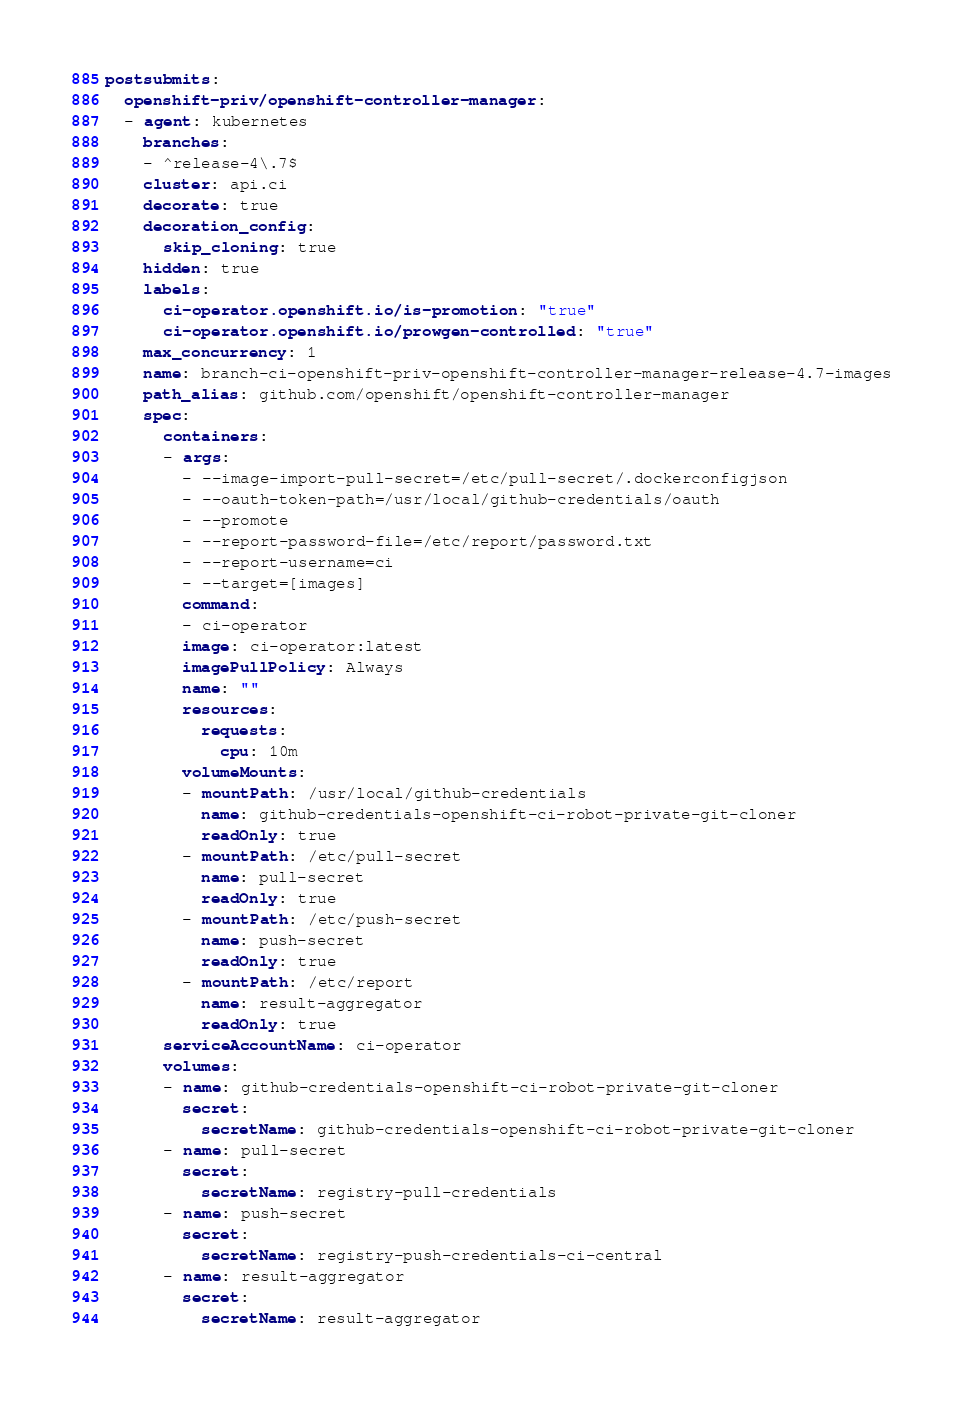Convert code to text. <code><loc_0><loc_0><loc_500><loc_500><_YAML_>postsubmits:
  openshift-priv/openshift-controller-manager:
  - agent: kubernetes
    branches:
    - ^release-4\.7$
    cluster: api.ci
    decorate: true
    decoration_config:
      skip_cloning: true
    hidden: true
    labels:
      ci-operator.openshift.io/is-promotion: "true"
      ci-operator.openshift.io/prowgen-controlled: "true"
    max_concurrency: 1
    name: branch-ci-openshift-priv-openshift-controller-manager-release-4.7-images
    path_alias: github.com/openshift/openshift-controller-manager
    spec:
      containers:
      - args:
        - --image-import-pull-secret=/etc/pull-secret/.dockerconfigjson
        - --oauth-token-path=/usr/local/github-credentials/oauth
        - --promote
        - --report-password-file=/etc/report/password.txt
        - --report-username=ci
        - --target=[images]
        command:
        - ci-operator
        image: ci-operator:latest
        imagePullPolicy: Always
        name: ""
        resources:
          requests:
            cpu: 10m
        volumeMounts:
        - mountPath: /usr/local/github-credentials
          name: github-credentials-openshift-ci-robot-private-git-cloner
          readOnly: true
        - mountPath: /etc/pull-secret
          name: pull-secret
          readOnly: true
        - mountPath: /etc/push-secret
          name: push-secret
          readOnly: true
        - mountPath: /etc/report
          name: result-aggregator
          readOnly: true
      serviceAccountName: ci-operator
      volumes:
      - name: github-credentials-openshift-ci-robot-private-git-cloner
        secret:
          secretName: github-credentials-openshift-ci-robot-private-git-cloner
      - name: pull-secret
        secret:
          secretName: registry-pull-credentials
      - name: push-secret
        secret:
          secretName: registry-push-credentials-ci-central
      - name: result-aggregator
        secret:
          secretName: result-aggregator
</code> 